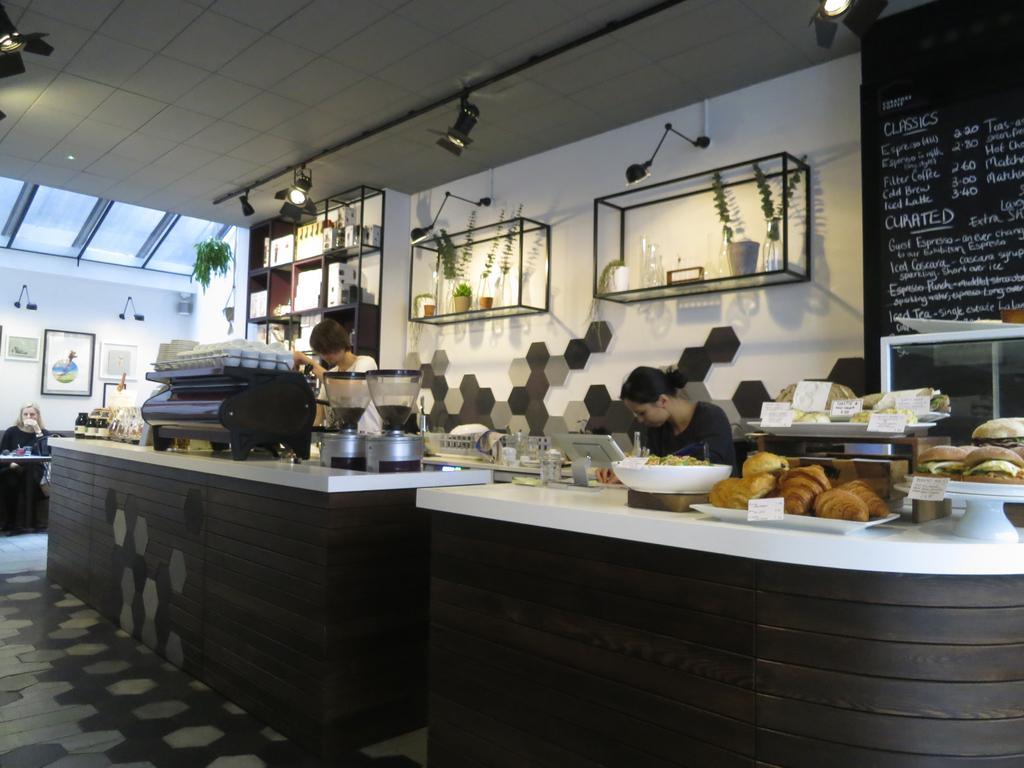Can you describe this image briefly? This is a cafeteria which has two long tables and on the table we have some stands which are used for putting the things and the coffee maker and on the other table we have some buns and burgers on the tables. To the wall side we have two shelves in which the plants are placed and some show lights which are placed. And there are two people in the cabin and on the top left side there is list of items and their price. 